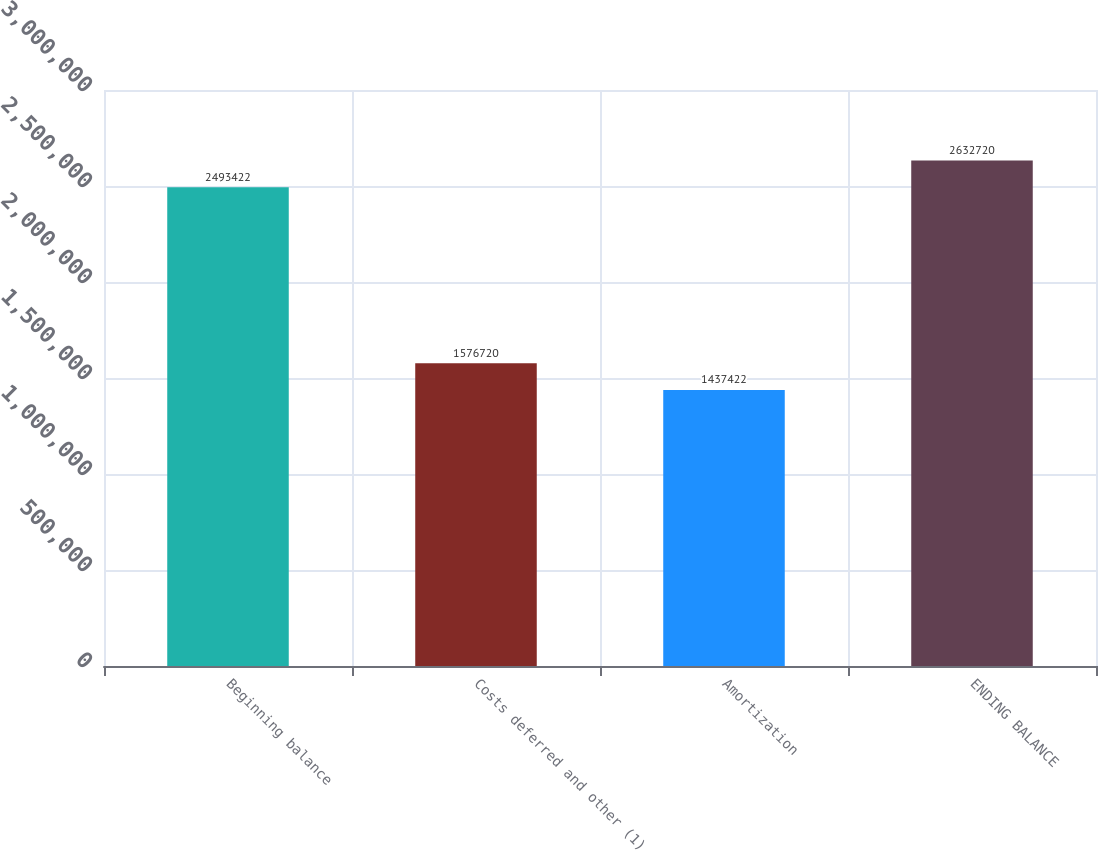Convert chart to OTSL. <chart><loc_0><loc_0><loc_500><loc_500><bar_chart><fcel>Beginning balance<fcel>Costs deferred and other (1)<fcel>Amortization<fcel>ENDING BALANCE<nl><fcel>2.49342e+06<fcel>1.57672e+06<fcel>1.43742e+06<fcel>2.63272e+06<nl></chart> 